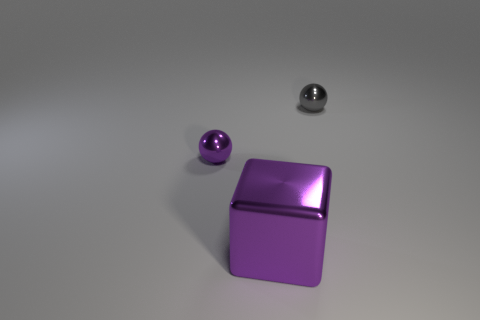Are the purple sphere and the large cube that is in front of the small gray thing made of the same material?
Provide a succinct answer. Yes. What color is the small shiny thing behind the small ball that is left of the tiny metal ball that is on the right side of the tiny purple ball?
Make the answer very short. Gray. How many other objects are the same shape as the small purple thing?
Ensure brevity in your answer.  1. How many objects are either tiny green metallic blocks or things behind the large purple metal thing?
Make the answer very short. 2. Is there a gray shiny thing of the same size as the purple ball?
Provide a short and direct response. Yes. Does the small purple sphere have the same material as the tiny gray object?
Offer a terse response. Yes. How many objects are either small gray metal balls or small purple metal spheres?
Ensure brevity in your answer.  2. How big is the metallic cube?
Give a very brief answer. Large. Are there fewer large things than large gray rubber cubes?
Offer a terse response. No. What number of other things have the same color as the large thing?
Your answer should be compact. 1. 